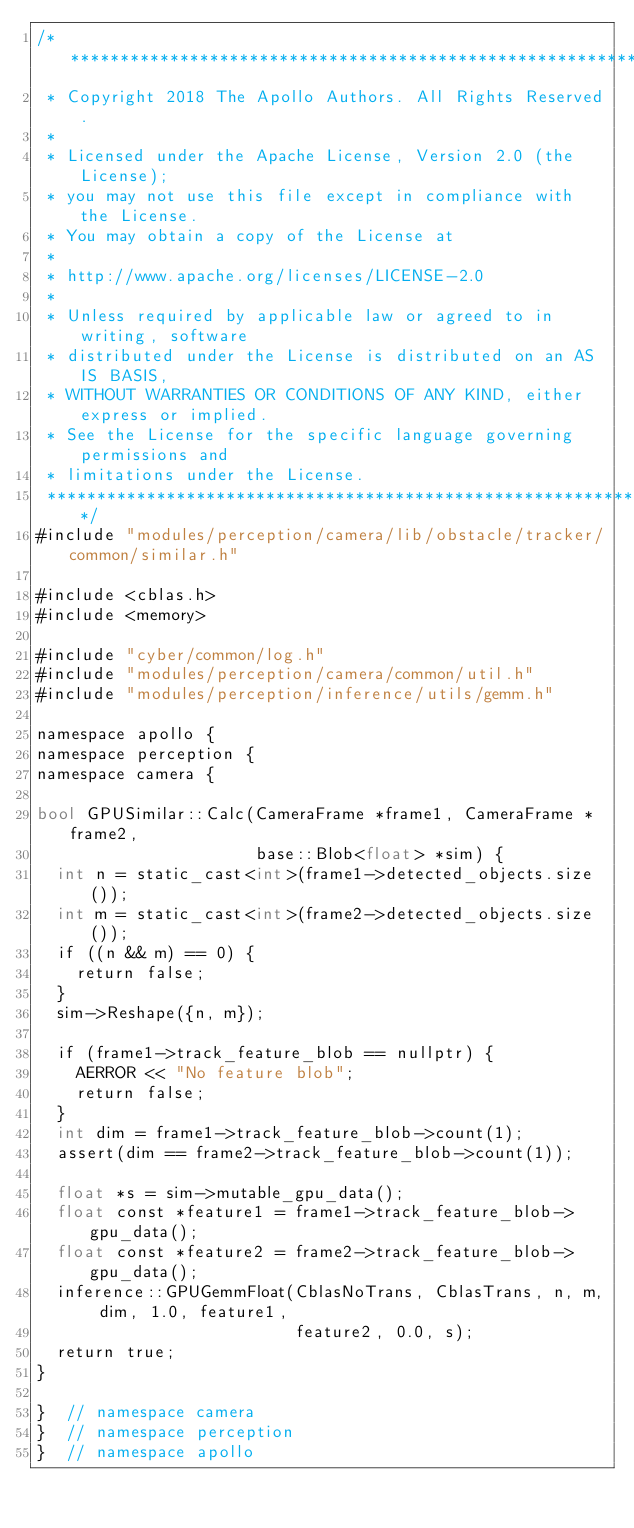Convert code to text. <code><loc_0><loc_0><loc_500><loc_500><_Cuda_>/******************************************************************************
 * Copyright 2018 The Apollo Authors. All Rights Reserved.
 *
 * Licensed under the Apache License, Version 2.0 (the License);
 * you may not use this file except in compliance with the License.
 * You may obtain a copy of the License at
 *
 * http://www.apache.org/licenses/LICENSE-2.0
 *
 * Unless required by applicable law or agreed to in writing, software
 * distributed under the License is distributed on an AS IS BASIS,
 * WITHOUT WARRANTIES OR CONDITIONS OF ANY KIND, either express or implied.
 * See the License for the specific language governing permissions and
 * limitations under the License.
 *****************************************************************************/
#include "modules/perception/camera/lib/obstacle/tracker/common/similar.h"

#include <cblas.h>
#include <memory>

#include "cyber/common/log.h"
#include "modules/perception/camera/common/util.h"
#include "modules/perception/inference/utils/gemm.h"

namespace apollo {
namespace perception {
namespace camera {

bool GPUSimilar::Calc(CameraFrame *frame1, CameraFrame *frame2,
                      base::Blob<float> *sim) {
  int n = static_cast<int>(frame1->detected_objects.size());
  int m = static_cast<int>(frame2->detected_objects.size());
  if ((n && m) == 0) {
    return false;
  }
  sim->Reshape({n, m});

  if (frame1->track_feature_blob == nullptr) {
    AERROR << "No feature blob";
    return false;
  }
  int dim = frame1->track_feature_blob->count(1);
  assert(dim == frame2->track_feature_blob->count(1));

  float *s = sim->mutable_gpu_data();
  float const *feature1 = frame1->track_feature_blob->gpu_data();
  float const *feature2 = frame2->track_feature_blob->gpu_data();
  inference::GPUGemmFloat(CblasNoTrans, CblasTrans, n, m, dim, 1.0, feature1,
                          feature2, 0.0, s);
  return true;
}

}  // namespace camera
}  // namespace perception
}  // namespace apollo
</code> 